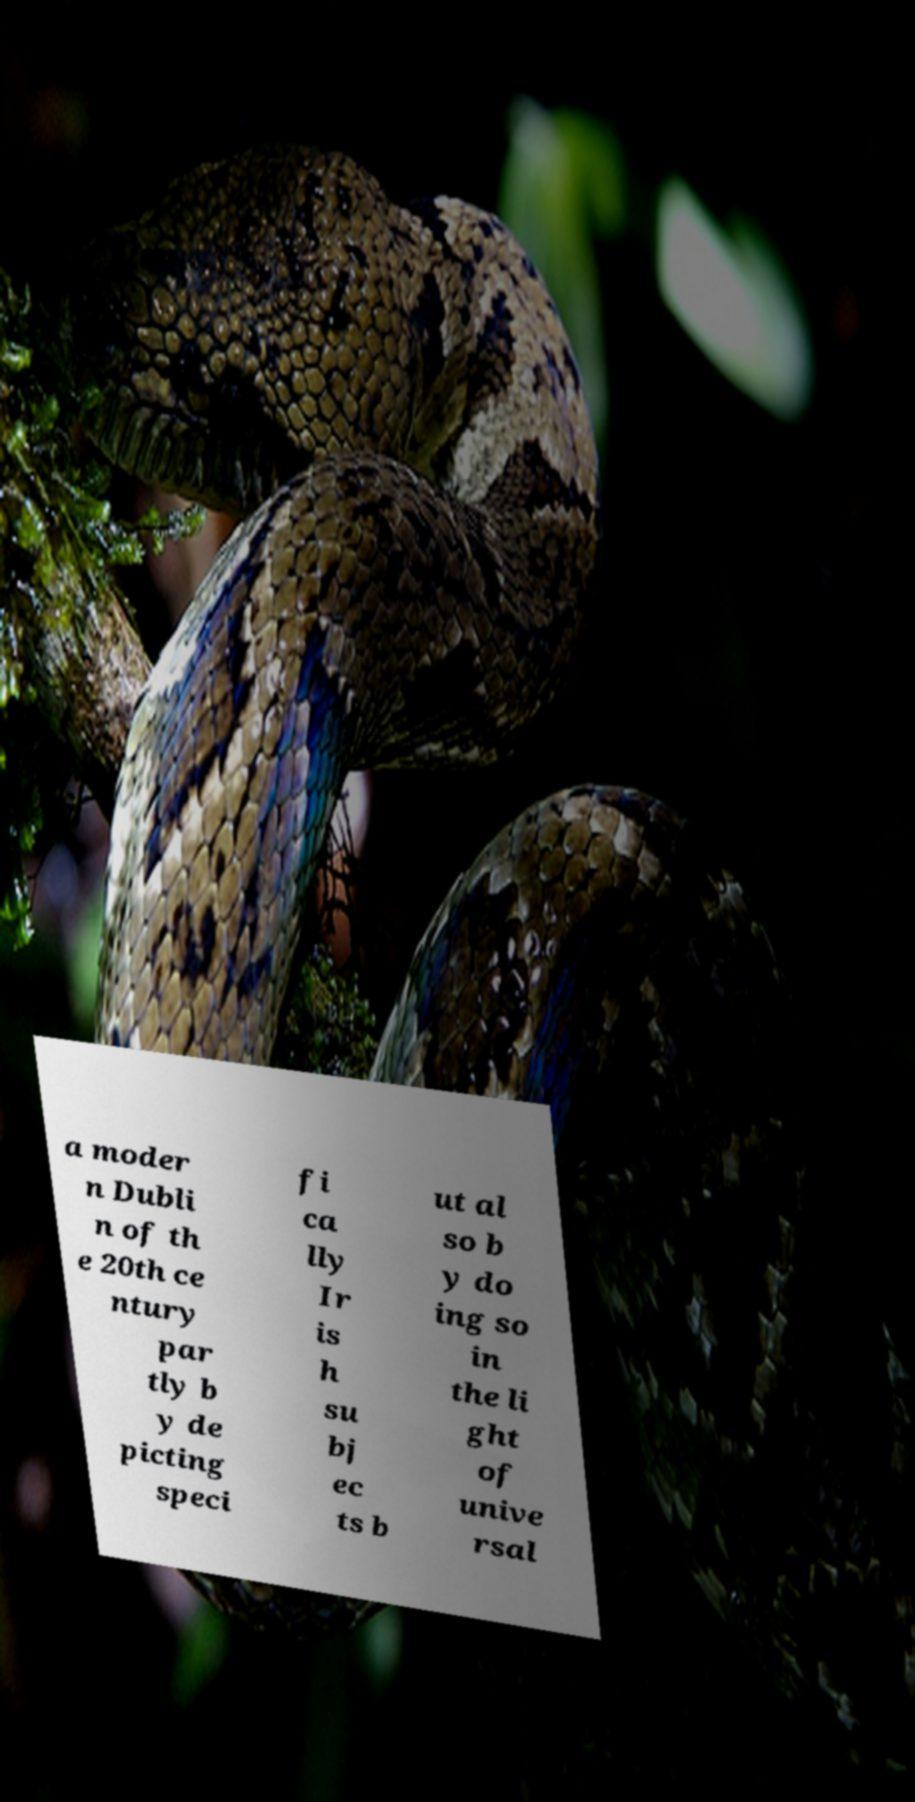What messages or text are displayed in this image? I need them in a readable, typed format. a moder n Dubli n of th e 20th ce ntury par tly b y de picting speci fi ca lly Ir is h su bj ec ts b ut al so b y do ing so in the li ght of unive rsal 